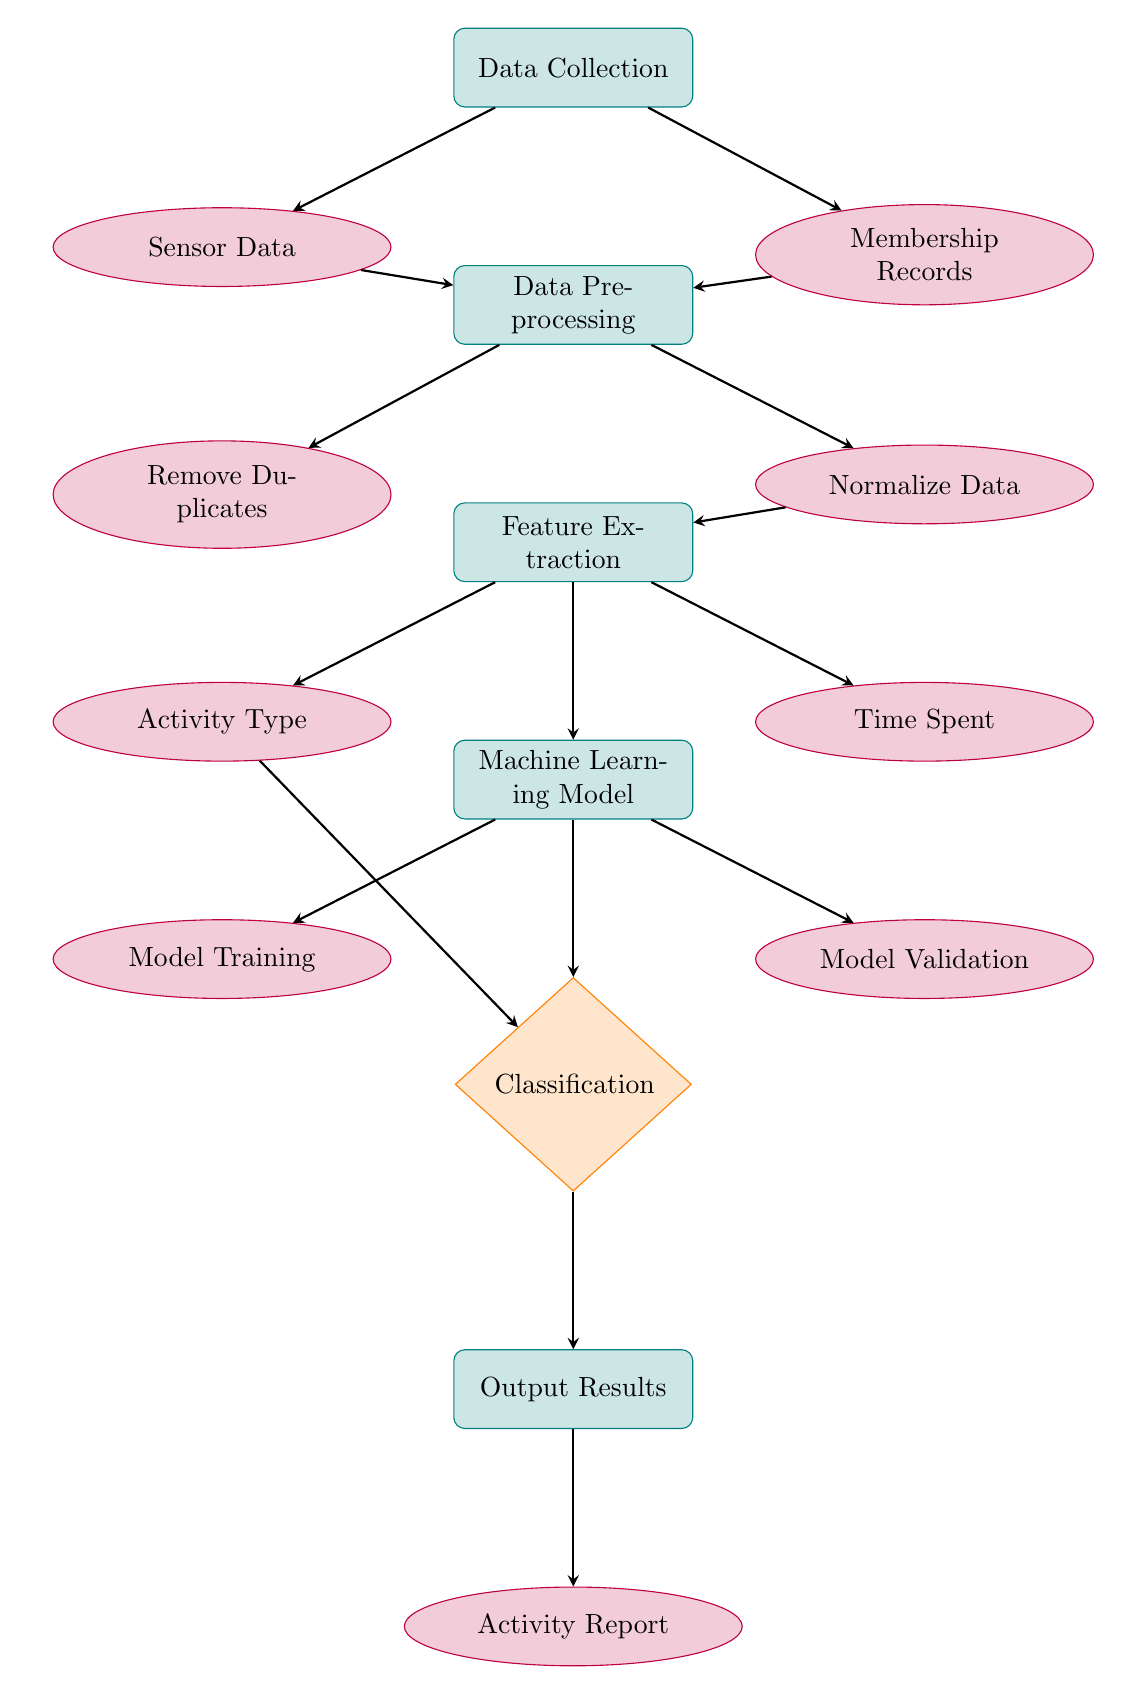What are the two main data sources in the diagram? The two main data sources are represented by the nodes connected to the Data Collection process, which are Sensor Data and Membership Records. These nodes are visually distinguished and linked directly to the Data Collection step, indicating their roles as data inputs.
Answer: Sensor Data, Membership Records How many processes are shown in the diagram? By counting the nodes classified under the 'process' style, we see there are five distinct processes: Data Collection, Data Preprocessing, Feature Extraction, Machine Learning Model, and Output Results. Thus, the total number of processes is determined by identifying these nodes specifically.
Answer: Five What type of data is produced after the classification step? After the Classification step, the diagram indicates that the result is an Activity Report. This node is connected as the output to the classification decision, thus providing a clear output of the overall process.
Answer: Activity Report Which step follows Model Training? Based on the sequence of arrows depicted in the diagram, Model Validation follows Model Training as the next process. This relationship is shown by the directed arrow indicating the flow from model training to model validation.
Answer: Model Validation How are duplicates handled in this process? The Data Preprocessing step includes a specific task, Remove Duplicates, indicating that handling duplicates occurs as part of this preprocessing process. The arrow connecting Data Preprocessing to Remove Duplicates signifies this clear action taken in the workflow.
Answer: Remove Duplicates What is the purpose of the Feature Extraction step? Feature Extraction serves to determine key components for further analysis, specifically extracting Activity Type and Time Spent, which are critical features to analyze in the context of the overall machine learning process. This is evident from the connections shown as output from Feature Extraction.
Answer: Extract features How many outputs are produced from the Machine Learning Model? The Machine Learning Model yields three outputs: Model Training, Model Validation, and Classification. Each of these outputs is explicitly shown with arrows emanating from the Machine Learning Model node, thus confirming the number of outputs.
Answer: Three What decision is made in the classification step? The classification step involves making a choice based on inputs from the Feature Extraction results, specifically to categorize the activities based on previously defined criteria, as outlined in the Classification node. The direct flow of data into this decision node reflects the criteria-based judgement occurring here.
Answer: Classification 